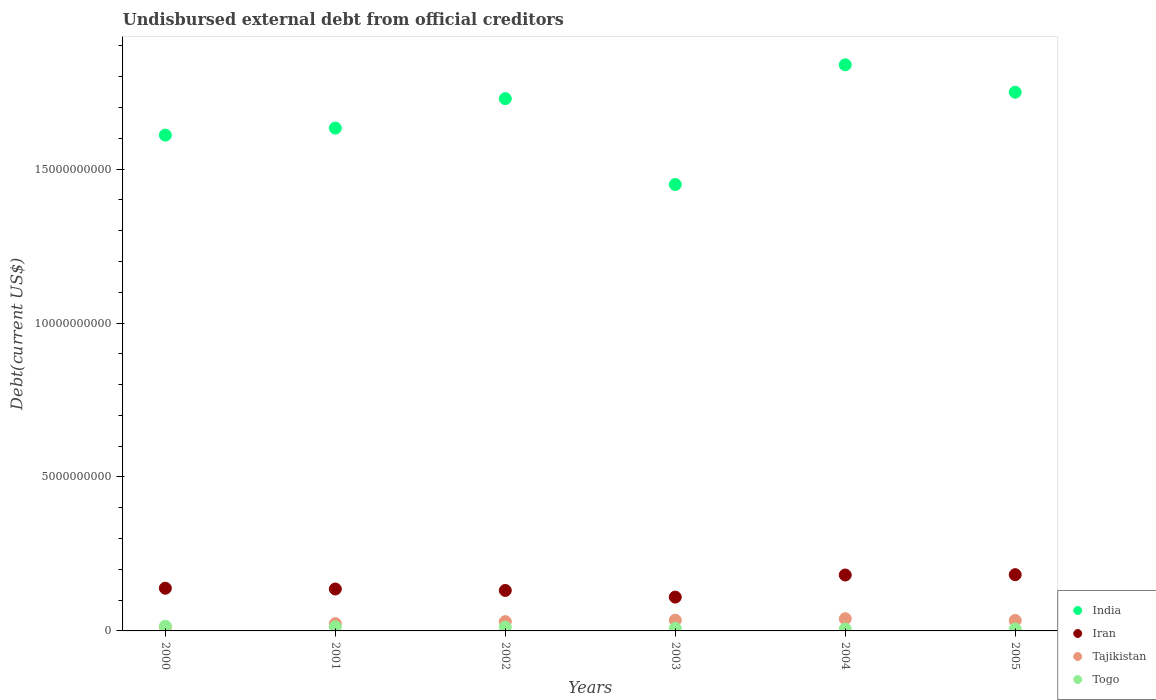Is the number of dotlines equal to the number of legend labels?
Make the answer very short. Yes. What is the total debt in Iran in 2004?
Keep it short and to the point. 1.82e+09. Across all years, what is the maximum total debt in Togo?
Provide a succinct answer. 1.53e+08. Across all years, what is the minimum total debt in Togo?
Offer a very short reply. 6.17e+07. What is the total total debt in Iran in the graph?
Offer a terse response. 8.80e+09. What is the difference between the total debt in Iran in 2000 and that in 2001?
Your answer should be very brief. 2.49e+07. What is the difference between the total debt in Iran in 2001 and the total debt in India in 2005?
Provide a succinct answer. -1.61e+1. What is the average total debt in India per year?
Offer a terse response. 1.67e+1. In the year 2002, what is the difference between the total debt in Tajikistan and total debt in Togo?
Your answer should be very brief. 1.81e+08. What is the ratio of the total debt in India in 2002 to that in 2003?
Provide a short and direct response. 1.19. Is the total debt in Togo in 2001 less than that in 2005?
Ensure brevity in your answer.  No. What is the difference between the highest and the second highest total debt in India?
Provide a short and direct response. 8.91e+08. What is the difference between the highest and the lowest total debt in Togo?
Keep it short and to the point. 9.15e+07. Is it the case that in every year, the sum of the total debt in Iran and total debt in Tajikistan  is greater than the total debt in Togo?
Your answer should be compact. Yes. Does the total debt in Tajikistan monotonically increase over the years?
Your response must be concise. No. Is the total debt in Iran strictly greater than the total debt in India over the years?
Provide a succinct answer. No. How many dotlines are there?
Offer a terse response. 4. How many years are there in the graph?
Provide a short and direct response. 6. Where does the legend appear in the graph?
Your answer should be very brief. Bottom right. How many legend labels are there?
Your response must be concise. 4. What is the title of the graph?
Provide a succinct answer. Undisbursed external debt from official creditors. Does "Samoa" appear as one of the legend labels in the graph?
Offer a very short reply. No. What is the label or title of the X-axis?
Keep it short and to the point. Years. What is the label or title of the Y-axis?
Your answer should be very brief. Debt(current US$). What is the Debt(current US$) of India in 2000?
Ensure brevity in your answer.  1.61e+1. What is the Debt(current US$) in Iran in 2000?
Provide a short and direct response. 1.39e+09. What is the Debt(current US$) of Tajikistan in 2000?
Your response must be concise. 1.18e+08. What is the Debt(current US$) of Togo in 2000?
Your answer should be very brief. 1.53e+08. What is the Debt(current US$) of India in 2001?
Offer a very short reply. 1.63e+1. What is the Debt(current US$) in Iran in 2001?
Make the answer very short. 1.36e+09. What is the Debt(current US$) in Tajikistan in 2001?
Your answer should be very brief. 2.36e+08. What is the Debt(current US$) in Togo in 2001?
Your response must be concise. 1.32e+08. What is the Debt(current US$) of India in 2002?
Your answer should be compact. 1.73e+1. What is the Debt(current US$) in Iran in 2002?
Ensure brevity in your answer.  1.31e+09. What is the Debt(current US$) in Tajikistan in 2002?
Your response must be concise. 3.02e+08. What is the Debt(current US$) of Togo in 2002?
Make the answer very short. 1.21e+08. What is the Debt(current US$) of India in 2003?
Your answer should be compact. 1.45e+1. What is the Debt(current US$) in Iran in 2003?
Your response must be concise. 1.10e+09. What is the Debt(current US$) of Tajikistan in 2003?
Offer a terse response. 3.47e+08. What is the Debt(current US$) in Togo in 2003?
Your answer should be compact. 8.25e+07. What is the Debt(current US$) of India in 2004?
Offer a terse response. 1.84e+1. What is the Debt(current US$) in Iran in 2004?
Provide a succinct answer. 1.82e+09. What is the Debt(current US$) of Tajikistan in 2004?
Keep it short and to the point. 3.96e+08. What is the Debt(current US$) in Togo in 2004?
Keep it short and to the point. 6.29e+07. What is the Debt(current US$) in India in 2005?
Make the answer very short. 1.75e+1. What is the Debt(current US$) of Iran in 2005?
Give a very brief answer. 1.83e+09. What is the Debt(current US$) of Tajikistan in 2005?
Your answer should be very brief. 3.39e+08. What is the Debt(current US$) in Togo in 2005?
Your response must be concise. 6.17e+07. Across all years, what is the maximum Debt(current US$) of India?
Offer a very short reply. 1.84e+1. Across all years, what is the maximum Debt(current US$) of Iran?
Provide a succinct answer. 1.83e+09. Across all years, what is the maximum Debt(current US$) of Tajikistan?
Provide a short and direct response. 3.96e+08. Across all years, what is the maximum Debt(current US$) of Togo?
Your answer should be very brief. 1.53e+08. Across all years, what is the minimum Debt(current US$) of India?
Offer a very short reply. 1.45e+1. Across all years, what is the minimum Debt(current US$) in Iran?
Your response must be concise. 1.10e+09. Across all years, what is the minimum Debt(current US$) in Tajikistan?
Give a very brief answer. 1.18e+08. Across all years, what is the minimum Debt(current US$) in Togo?
Provide a succinct answer. 6.17e+07. What is the total Debt(current US$) in India in the graph?
Give a very brief answer. 1.00e+11. What is the total Debt(current US$) in Iran in the graph?
Offer a very short reply. 8.80e+09. What is the total Debt(current US$) of Tajikistan in the graph?
Offer a terse response. 1.74e+09. What is the total Debt(current US$) of Togo in the graph?
Your answer should be compact. 6.13e+08. What is the difference between the Debt(current US$) of India in 2000 and that in 2001?
Keep it short and to the point. -2.29e+08. What is the difference between the Debt(current US$) of Iran in 2000 and that in 2001?
Provide a succinct answer. 2.49e+07. What is the difference between the Debt(current US$) in Tajikistan in 2000 and that in 2001?
Offer a very short reply. -1.18e+08. What is the difference between the Debt(current US$) in Togo in 2000 and that in 2001?
Keep it short and to the point. 2.13e+07. What is the difference between the Debt(current US$) of India in 2000 and that in 2002?
Offer a very short reply. -1.18e+09. What is the difference between the Debt(current US$) of Iran in 2000 and that in 2002?
Make the answer very short. 7.25e+07. What is the difference between the Debt(current US$) of Tajikistan in 2000 and that in 2002?
Ensure brevity in your answer.  -1.84e+08. What is the difference between the Debt(current US$) in Togo in 2000 and that in 2002?
Your answer should be compact. 3.19e+07. What is the difference between the Debt(current US$) of India in 2000 and that in 2003?
Your response must be concise. 1.60e+09. What is the difference between the Debt(current US$) of Iran in 2000 and that in 2003?
Your answer should be very brief. 2.88e+08. What is the difference between the Debt(current US$) of Tajikistan in 2000 and that in 2003?
Ensure brevity in your answer.  -2.30e+08. What is the difference between the Debt(current US$) in Togo in 2000 and that in 2003?
Your answer should be very brief. 7.07e+07. What is the difference between the Debt(current US$) of India in 2000 and that in 2004?
Ensure brevity in your answer.  -2.28e+09. What is the difference between the Debt(current US$) in Iran in 2000 and that in 2004?
Provide a succinct answer. -4.29e+08. What is the difference between the Debt(current US$) in Tajikistan in 2000 and that in 2004?
Ensure brevity in your answer.  -2.78e+08. What is the difference between the Debt(current US$) in Togo in 2000 and that in 2004?
Keep it short and to the point. 9.02e+07. What is the difference between the Debt(current US$) in India in 2000 and that in 2005?
Your response must be concise. -1.39e+09. What is the difference between the Debt(current US$) in Iran in 2000 and that in 2005?
Provide a succinct answer. -4.40e+08. What is the difference between the Debt(current US$) in Tajikistan in 2000 and that in 2005?
Provide a succinct answer. -2.22e+08. What is the difference between the Debt(current US$) of Togo in 2000 and that in 2005?
Keep it short and to the point. 9.15e+07. What is the difference between the Debt(current US$) in India in 2001 and that in 2002?
Offer a terse response. -9.56e+08. What is the difference between the Debt(current US$) in Iran in 2001 and that in 2002?
Your answer should be compact. 4.77e+07. What is the difference between the Debt(current US$) in Tajikistan in 2001 and that in 2002?
Keep it short and to the point. -6.63e+07. What is the difference between the Debt(current US$) of Togo in 2001 and that in 2002?
Ensure brevity in your answer.  1.05e+07. What is the difference between the Debt(current US$) in India in 2001 and that in 2003?
Make the answer very short. 1.83e+09. What is the difference between the Debt(current US$) in Iran in 2001 and that in 2003?
Your answer should be compact. 2.64e+08. What is the difference between the Debt(current US$) in Tajikistan in 2001 and that in 2003?
Make the answer very short. -1.12e+08. What is the difference between the Debt(current US$) of Togo in 2001 and that in 2003?
Your answer should be compact. 4.94e+07. What is the difference between the Debt(current US$) in India in 2001 and that in 2004?
Ensure brevity in your answer.  -2.06e+09. What is the difference between the Debt(current US$) of Iran in 2001 and that in 2004?
Keep it short and to the point. -4.54e+08. What is the difference between the Debt(current US$) of Tajikistan in 2001 and that in 2004?
Offer a terse response. -1.60e+08. What is the difference between the Debt(current US$) in Togo in 2001 and that in 2004?
Give a very brief answer. 6.89e+07. What is the difference between the Debt(current US$) of India in 2001 and that in 2005?
Provide a short and direct response. -1.16e+09. What is the difference between the Debt(current US$) of Iran in 2001 and that in 2005?
Provide a succinct answer. -4.65e+08. What is the difference between the Debt(current US$) in Tajikistan in 2001 and that in 2005?
Provide a short and direct response. -1.04e+08. What is the difference between the Debt(current US$) of Togo in 2001 and that in 2005?
Give a very brief answer. 7.02e+07. What is the difference between the Debt(current US$) of India in 2002 and that in 2003?
Your answer should be compact. 2.79e+09. What is the difference between the Debt(current US$) of Iran in 2002 and that in 2003?
Your answer should be very brief. 2.16e+08. What is the difference between the Debt(current US$) of Tajikistan in 2002 and that in 2003?
Provide a short and direct response. -4.55e+07. What is the difference between the Debt(current US$) in Togo in 2002 and that in 2003?
Offer a terse response. 3.88e+07. What is the difference between the Debt(current US$) in India in 2002 and that in 2004?
Ensure brevity in your answer.  -1.10e+09. What is the difference between the Debt(current US$) of Iran in 2002 and that in 2004?
Provide a short and direct response. -5.02e+08. What is the difference between the Debt(current US$) of Tajikistan in 2002 and that in 2004?
Your response must be concise. -9.41e+07. What is the difference between the Debt(current US$) in Togo in 2002 and that in 2004?
Offer a very short reply. 5.84e+07. What is the difference between the Debt(current US$) in India in 2002 and that in 2005?
Make the answer very short. -2.09e+08. What is the difference between the Debt(current US$) of Iran in 2002 and that in 2005?
Give a very brief answer. -5.12e+08. What is the difference between the Debt(current US$) in Tajikistan in 2002 and that in 2005?
Your answer should be compact. -3.75e+07. What is the difference between the Debt(current US$) of Togo in 2002 and that in 2005?
Provide a succinct answer. 5.96e+07. What is the difference between the Debt(current US$) of India in 2003 and that in 2004?
Keep it short and to the point. -3.89e+09. What is the difference between the Debt(current US$) of Iran in 2003 and that in 2004?
Offer a very short reply. -7.18e+08. What is the difference between the Debt(current US$) in Tajikistan in 2003 and that in 2004?
Offer a very short reply. -4.86e+07. What is the difference between the Debt(current US$) in Togo in 2003 and that in 2004?
Offer a very short reply. 1.96e+07. What is the difference between the Debt(current US$) of India in 2003 and that in 2005?
Give a very brief answer. -3.00e+09. What is the difference between the Debt(current US$) of Iran in 2003 and that in 2005?
Provide a short and direct response. -7.28e+08. What is the difference between the Debt(current US$) of Tajikistan in 2003 and that in 2005?
Keep it short and to the point. 8.02e+06. What is the difference between the Debt(current US$) in Togo in 2003 and that in 2005?
Ensure brevity in your answer.  2.08e+07. What is the difference between the Debt(current US$) of India in 2004 and that in 2005?
Offer a terse response. 8.91e+08. What is the difference between the Debt(current US$) in Iran in 2004 and that in 2005?
Give a very brief answer. -1.07e+07. What is the difference between the Debt(current US$) of Tajikistan in 2004 and that in 2005?
Your answer should be compact. 5.66e+07. What is the difference between the Debt(current US$) in Togo in 2004 and that in 2005?
Make the answer very short. 1.24e+06. What is the difference between the Debt(current US$) in India in 2000 and the Debt(current US$) in Iran in 2001?
Your answer should be very brief. 1.47e+1. What is the difference between the Debt(current US$) in India in 2000 and the Debt(current US$) in Tajikistan in 2001?
Make the answer very short. 1.59e+1. What is the difference between the Debt(current US$) of India in 2000 and the Debt(current US$) of Togo in 2001?
Make the answer very short. 1.60e+1. What is the difference between the Debt(current US$) in Iran in 2000 and the Debt(current US$) in Tajikistan in 2001?
Offer a very short reply. 1.15e+09. What is the difference between the Debt(current US$) in Iran in 2000 and the Debt(current US$) in Togo in 2001?
Make the answer very short. 1.25e+09. What is the difference between the Debt(current US$) in Tajikistan in 2000 and the Debt(current US$) in Togo in 2001?
Make the answer very short. -1.42e+07. What is the difference between the Debt(current US$) in India in 2000 and the Debt(current US$) in Iran in 2002?
Provide a succinct answer. 1.48e+1. What is the difference between the Debt(current US$) in India in 2000 and the Debt(current US$) in Tajikistan in 2002?
Make the answer very short. 1.58e+1. What is the difference between the Debt(current US$) of India in 2000 and the Debt(current US$) of Togo in 2002?
Make the answer very short. 1.60e+1. What is the difference between the Debt(current US$) in Iran in 2000 and the Debt(current US$) in Tajikistan in 2002?
Ensure brevity in your answer.  1.08e+09. What is the difference between the Debt(current US$) in Iran in 2000 and the Debt(current US$) in Togo in 2002?
Your response must be concise. 1.27e+09. What is the difference between the Debt(current US$) of Tajikistan in 2000 and the Debt(current US$) of Togo in 2002?
Give a very brief answer. -3.70e+06. What is the difference between the Debt(current US$) of India in 2000 and the Debt(current US$) of Iran in 2003?
Your answer should be compact. 1.50e+1. What is the difference between the Debt(current US$) in India in 2000 and the Debt(current US$) in Tajikistan in 2003?
Offer a very short reply. 1.58e+1. What is the difference between the Debt(current US$) of India in 2000 and the Debt(current US$) of Togo in 2003?
Your response must be concise. 1.60e+1. What is the difference between the Debt(current US$) in Iran in 2000 and the Debt(current US$) in Tajikistan in 2003?
Your answer should be very brief. 1.04e+09. What is the difference between the Debt(current US$) of Iran in 2000 and the Debt(current US$) of Togo in 2003?
Provide a short and direct response. 1.30e+09. What is the difference between the Debt(current US$) in Tajikistan in 2000 and the Debt(current US$) in Togo in 2003?
Ensure brevity in your answer.  3.51e+07. What is the difference between the Debt(current US$) in India in 2000 and the Debt(current US$) in Iran in 2004?
Provide a short and direct response. 1.43e+1. What is the difference between the Debt(current US$) in India in 2000 and the Debt(current US$) in Tajikistan in 2004?
Keep it short and to the point. 1.57e+1. What is the difference between the Debt(current US$) in India in 2000 and the Debt(current US$) in Togo in 2004?
Make the answer very short. 1.60e+1. What is the difference between the Debt(current US$) of Iran in 2000 and the Debt(current US$) of Tajikistan in 2004?
Make the answer very short. 9.91e+08. What is the difference between the Debt(current US$) in Iran in 2000 and the Debt(current US$) in Togo in 2004?
Your response must be concise. 1.32e+09. What is the difference between the Debt(current US$) in Tajikistan in 2000 and the Debt(current US$) in Togo in 2004?
Ensure brevity in your answer.  5.47e+07. What is the difference between the Debt(current US$) in India in 2000 and the Debt(current US$) in Iran in 2005?
Provide a succinct answer. 1.43e+1. What is the difference between the Debt(current US$) in India in 2000 and the Debt(current US$) in Tajikistan in 2005?
Offer a very short reply. 1.58e+1. What is the difference between the Debt(current US$) in India in 2000 and the Debt(current US$) in Togo in 2005?
Offer a very short reply. 1.60e+1. What is the difference between the Debt(current US$) in Iran in 2000 and the Debt(current US$) in Tajikistan in 2005?
Ensure brevity in your answer.  1.05e+09. What is the difference between the Debt(current US$) in Iran in 2000 and the Debt(current US$) in Togo in 2005?
Give a very brief answer. 1.33e+09. What is the difference between the Debt(current US$) in Tajikistan in 2000 and the Debt(current US$) in Togo in 2005?
Provide a succinct answer. 5.59e+07. What is the difference between the Debt(current US$) of India in 2001 and the Debt(current US$) of Iran in 2002?
Make the answer very short. 1.50e+1. What is the difference between the Debt(current US$) of India in 2001 and the Debt(current US$) of Tajikistan in 2002?
Your response must be concise. 1.60e+1. What is the difference between the Debt(current US$) in India in 2001 and the Debt(current US$) in Togo in 2002?
Make the answer very short. 1.62e+1. What is the difference between the Debt(current US$) in Iran in 2001 and the Debt(current US$) in Tajikistan in 2002?
Provide a succinct answer. 1.06e+09. What is the difference between the Debt(current US$) in Iran in 2001 and the Debt(current US$) in Togo in 2002?
Ensure brevity in your answer.  1.24e+09. What is the difference between the Debt(current US$) of Tajikistan in 2001 and the Debt(current US$) of Togo in 2002?
Keep it short and to the point. 1.14e+08. What is the difference between the Debt(current US$) of India in 2001 and the Debt(current US$) of Iran in 2003?
Provide a succinct answer. 1.52e+1. What is the difference between the Debt(current US$) of India in 2001 and the Debt(current US$) of Tajikistan in 2003?
Your answer should be compact. 1.60e+1. What is the difference between the Debt(current US$) of India in 2001 and the Debt(current US$) of Togo in 2003?
Give a very brief answer. 1.62e+1. What is the difference between the Debt(current US$) in Iran in 2001 and the Debt(current US$) in Tajikistan in 2003?
Offer a terse response. 1.01e+09. What is the difference between the Debt(current US$) in Iran in 2001 and the Debt(current US$) in Togo in 2003?
Provide a short and direct response. 1.28e+09. What is the difference between the Debt(current US$) in Tajikistan in 2001 and the Debt(current US$) in Togo in 2003?
Your answer should be compact. 1.53e+08. What is the difference between the Debt(current US$) in India in 2001 and the Debt(current US$) in Iran in 2004?
Make the answer very short. 1.45e+1. What is the difference between the Debt(current US$) of India in 2001 and the Debt(current US$) of Tajikistan in 2004?
Give a very brief answer. 1.59e+1. What is the difference between the Debt(current US$) in India in 2001 and the Debt(current US$) in Togo in 2004?
Ensure brevity in your answer.  1.63e+1. What is the difference between the Debt(current US$) of Iran in 2001 and the Debt(current US$) of Tajikistan in 2004?
Ensure brevity in your answer.  9.66e+08. What is the difference between the Debt(current US$) in Iran in 2001 and the Debt(current US$) in Togo in 2004?
Make the answer very short. 1.30e+09. What is the difference between the Debt(current US$) in Tajikistan in 2001 and the Debt(current US$) in Togo in 2004?
Your response must be concise. 1.73e+08. What is the difference between the Debt(current US$) in India in 2001 and the Debt(current US$) in Iran in 2005?
Give a very brief answer. 1.45e+1. What is the difference between the Debt(current US$) of India in 2001 and the Debt(current US$) of Tajikistan in 2005?
Provide a succinct answer. 1.60e+1. What is the difference between the Debt(current US$) of India in 2001 and the Debt(current US$) of Togo in 2005?
Ensure brevity in your answer.  1.63e+1. What is the difference between the Debt(current US$) of Iran in 2001 and the Debt(current US$) of Tajikistan in 2005?
Keep it short and to the point. 1.02e+09. What is the difference between the Debt(current US$) of Iran in 2001 and the Debt(current US$) of Togo in 2005?
Your answer should be compact. 1.30e+09. What is the difference between the Debt(current US$) of Tajikistan in 2001 and the Debt(current US$) of Togo in 2005?
Offer a terse response. 1.74e+08. What is the difference between the Debt(current US$) in India in 2002 and the Debt(current US$) in Iran in 2003?
Provide a short and direct response. 1.62e+1. What is the difference between the Debt(current US$) in India in 2002 and the Debt(current US$) in Tajikistan in 2003?
Your answer should be compact. 1.69e+1. What is the difference between the Debt(current US$) of India in 2002 and the Debt(current US$) of Togo in 2003?
Give a very brief answer. 1.72e+1. What is the difference between the Debt(current US$) of Iran in 2002 and the Debt(current US$) of Tajikistan in 2003?
Your response must be concise. 9.67e+08. What is the difference between the Debt(current US$) in Iran in 2002 and the Debt(current US$) in Togo in 2003?
Offer a very short reply. 1.23e+09. What is the difference between the Debt(current US$) of Tajikistan in 2002 and the Debt(current US$) of Togo in 2003?
Make the answer very short. 2.19e+08. What is the difference between the Debt(current US$) of India in 2002 and the Debt(current US$) of Iran in 2004?
Provide a succinct answer. 1.55e+1. What is the difference between the Debt(current US$) of India in 2002 and the Debt(current US$) of Tajikistan in 2004?
Offer a very short reply. 1.69e+1. What is the difference between the Debt(current US$) of India in 2002 and the Debt(current US$) of Togo in 2004?
Your answer should be compact. 1.72e+1. What is the difference between the Debt(current US$) in Iran in 2002 and the Debt(current US$) in Tajikistan in 2004?
Provide a succinct answer. 9.18e+08. What is the difference between the Debt(current US$) of Iran in 2002 and the Debt(current US$) of Togo in 2004?
Give a very brief answer. 1.25e+09. What is the difference between the Debt(current US$) of Tajikistan in 2002 and the Debt(current US$) of Togo in 2004?
Offer a very short reply. 2.39e+08. What is the difference between the Debt(current US$) in India in 2002 and the Debt(current US$) in Iran in 2005?
Make the answer very short. 1.55e+1. What is the difference between the Debt(current US$) in India in 2002 and the Debt(current US$) in Tajikistan in 2005?
Keep it short and to the point. 1.69e+1. What is the difference between the Debt(current US$) in India in 2002 and the Debt(current US$) in Togo in 2005?
Your answer should be compact. 1.72e+1. What is the difference between the Debt(current US$) of Iran in 2002 and the Debt(current US$) of Tajikistan in 2005?
Give a very brief answer. 9.75e+08. What is the difference between the Debt(current US$) in Iran in 2002 and the Debt(current US$) in Togo in 2005?
Make the answer very short. 1.25e+09. What is the difference between the Debt(current US$) of Tajikistan in 2002 and the Debt(current US$) of Togo in 2005?
Your answer should be very brief. 2.40e+08. What is the difference between the Debt(current US$) in India in 2003 and the Debt(current US$) in Iran in 2004?
Offer a terse response. 1.27e+1. What is the difference between the Debt(current US$) in India in 2003 and the Debt(current US$) in Tajikistan in 2004?
Your answer should be compact. 1.41e+1. What is the difference between the Debt(current US$) of India in 2003 and the Debt(current US$) of Togo in 2004?
Offer a terse response. 1.44e+1. What is the difference between the Debt(current US$) in Iran in 2003 and the Debt(current US$) in Tajikistan in 2004?
Give a very brief answer. 7.02e+08. What is the difference between the Debt(current US$) of Iran in 2003 and the Debt(current US$) of Togo in 2004?
Your answer should be very brief. 1.04e+09. What is the difference between the Debt(current US$) in Tajikistan in 2003 and the Debt(current US$) in Togo in 2004?
Your answer should be very brief. 2.84e+08. What is the difference between the Debt(current US$) of India in 2003 and the Debt(current US$) of Iran in 2005?
Keep it short and to the point. 1.27e+1. What is the difference between the Debt(current US$) of India in 2003 and the Debt(current US$) of Tajikistan in 2005?
Provide a short and direct response. 1.42e+1. What is the difference between the Debt(current US$) in India in 2003 and the Debt(current US$) in Togo in 2005?
Provide a short and direct response. 1.44e+1. What is the difference between the Debt(current US$) in Iran in 2003 and the Debt(current US$) in Tajikistan in 2005?
Offer a terse response. 7.59e+08. What is the difference between the Debt(current US$) in Iran in 2003 and the Debt(current US$) in Togo in 2005?
Give a very brief answer. 1.04e+09. What is the difference between the Debt(current US$) of Tajikistan in 2003 and the Debt(current US$) of Togo in 2005?
Offer a terse response. 2.86e+08. What is the difference between the Debt(current US$) in India in 2004 and the Debt(current US$) in Iran in 2005?
Keep it short and to the point. 1.66e+1. What is the difference between the Debt(current US$) in India in 2004 and the Debt(current US$) in Tajikistan in 2005?
Offer a terse response. 1.80e+1. What is the difference between the Debt(current US$) of India in 2004 and the Debt(current US$) of Togo in 2005?
Provide a succinct answer. 1.83e+1. What is the difference between the Debt(current US$) in Iran in 2004 and the Debt(current US$) in Tajikistan in 2005?
Make the answer very short. 1.48e+09. What is the difference between the Debt(current US$) in Iran in 2004 and the Debt(current US$) in Togo in 2005?
Your answer should be compact. 1.75e+09. What is the difference between the Debt(current US$) of Tajikistan in 2004 and the Debt(current US$) of Togo in 2005?
Your answer should be compact. 3.34e+08. What is the average Debt(current US$) of India per year?
Ensure brevity in your answer.  1.67e+1. What is the average Debt(current US$) of Iran per year?
Ensure brevity in your answer.  1.47e+09. What is the average Debt(current US$) in Tajikistan per year?
Make the answer very short. 2.90e+08. What is the average Debt(current US$) of Togo per year?
Provide a succinct answer. 1.02e+08. In the year 2000, what is the difference between the Debt(current US$) of India and Debt(current US$) of Iran?
Your answer should be very brief. 1.47e+1. In the year 2000, what is the difference between the Debt(current US$) in India and Debt(current US$) in Tajikistan?
Ensure brevity in your answer.  1.60e+1. In the year 2000, what is the difference between the Debt(current US$) of India and Debt(current US$) of Togo?
Provide a succinct answer. 1.59e+1. In the year 2000, what is the difference between the Debt(current US$) of Iran and Debt(current US$) of Tajikistan?
Give a very brief answer. 1.27e+09. In the year 2000, what is the difference between the Debt(current US$) in Iran and Debt(current US$) in Togo?
Offer a very short reply. 1.23e+09. In the year 2000, what is the difference between the Debt(current US$) in Tajikistan and Debt(current US$) in Togo?
Give a very brief answer. -3.56e+07. In the year 2001, what is the difference between the Debt(current US$) of India and Debt(current US$) of Iran?
Offer a very short reply. 1.50e+1. In the year 2001, what is the difference between the Debt(current US$) in India and Debt(current US$) in Tajikistan?
Ensure brevity in your answer.  1.61e+1. In the year 2001, what is the difference between the Debt(current US$) of India and Debt(current US$) of Togo?
Make the answer very short. 1.62e+1. In the year 2001, what is the difference between the Debt(current US$) of Iran and Debt(current US$) of Tajikistan?
Give a very brief answer. 1.13e+09. In the year 2001, what is the difference between the Debt(current US$) in Iran and Debt(current US$) in Togo?
Give a very brief answer. 1.23e+09. In the year 2001, what is the difference between the Debt(current US$) in Tajikistan and Debt(current US$) in Togo?
Ensure brevity in your answer.  1.04e+08. In the year 2002, what is the difference between the Debt(current US$) in India and Debt(current US$) in Iran?
Provide a succinct answer. 1.60e+1. In the year 2002, what is the difference between the Debt(current US$) in India and Debt(current US$) in Tajikistan?
Provide a succinct answer. 1.70e+1. In the year 2002, what is the difference between the Debt(current US$) in India and Debt(current US$) in Togo?
Your answer should be very brief. 1.72e+1. In the year 2002, what is the difference between the Debt(current US$) of Iran and Debt(current US$) of Tajikistan?
Provide a short and direct response. 1.01e+09. In the year 2002, what is the difference between the Debt(current US$) of Iran and Debt(current US$) of Togo?
Offer a very short reply. 1.19e+09. In the year 2002, what is the difference between the Debt(current US$) of Tajikistan and Debt(current US$) of Togo?
Provide a succinct answer. 1.81e+08. In the year 2003, what is the difference between the Debt(current US$) of India and Debt(current US$) of Iran?
Your response must be concise. 1.34e+1. In the year 2003, what is the difference between the Debt(current US$) of India and Debt(current US$) of Tajikistan?
Keep it short and to the point. 1.42e+1. In the year 2003, what is the difference between the Debt(current US$) of India and Debt(current US$) of Togo?
Offer a terse response. 1.44e+1. In the year 2003, what is the difference between the Debt(current US$) of Iran and Debt(current US$) of Tajikistan?
Offer a very short reply. 7.51e+08. In the year 2003, what is the difference between the Debt(current US$) in Iran and Debt(current US$) in Togo?
Ensure brevity in your answer.  1.02e+09. In the year 2003, what is the difference between the Debt(current US$) in Tajikistan and Debt(current US$) in Togo?
Make the answer very short. 2.65e+08. In the year 2004, what is the difference between the Debt(current US$) of India and Debt(current US$) of Iran?
Your answer should be compact. 1.66e+1. In the year 2004, what is the difference between the Debt(current US$) of India and Debt(current US$) of Tajikistan?
Make the answer very short. 1.80e+1. In the year 2004, what is the difference between the Debt(current US$) in India and Debt(current US$) in Togo?
Your response must be concise. 1.83e+1. In the year 2004, what is the difference between the Debt(current US$) of Iran and Debt(current US$) of Tajikistan?
Offer a terse response. 1.42e+09. In the year 2004, what is the difference between the Debt(current US$) of Iran and Debt(current US$) of Togo?
Keep it short and to the point. 1.75e+09. In the year 2004, what is the difference between the Debt(current US$) in Tajikistan and Debt(current US$) in Togo?
Give a very brief answer. 3.33e+08. In the year 2005, what is the difference between the Debt(current US$) of India and Debt(current US$) of Iran?
Your answer should be very brief. 1.57e+1. In the year 2005, what is the difference between the Debt(current US$) in India and Debt(current US$) in Tajikistan?
Offer a terse response. 1.72e+1. In the year 2005, what is the difference between the Debt(current US$) of India and Debt(current US$) of Togo?
Provide a succinct answer. 1.74e+1. In the year 2005, what is the difference between the Debt(current US$) of Iran and Debt(current US$) of Tajikistan?
Keep it short and to the point. 1.49e+09. In the year 2005, what is the difference between the Debt(current US$) of Iran and Debt(current US$) of Togo?
Your answer should be compact. 1.77e+09. In the year 2005, what is the difference between the Debt(current US$) in Tajikistan and Debt(current US$) in Togo?
Provide a succinct answer. 2.78e+08. What is the ratio of the Debt(current US$) in India in 2000 to that in 2001?
Keep it short and to the point. 0.99. What is the ratio of the Debt(current US$) in Iran in 2000 to that in 2001?
Provide a succinct answer. 1.02. What is the ratio of the Debt(current US$) of Tajikistan in 2000 to that in 2001?
Offer a terse response. 0.5. What is the ratio of the Debt(current US$) in Togo in 2000 to that in 2001?
Make the answer very short. 1.16. What is the ratio of the Debt(current US$) of India in 2000 to that in 2002?
Give a very brief answer. 0.93. What is the ratio of the Debt(current US$) in Iran in 2000 to that in 2002?
Ensure brevity in your answer.  1.06. What is the ratio of the Debt(current US$) in Tajikistan in 2000 to that in 2002?
Give a very brief answer. 0.39. What is the ratio of the Debt(current US$) in Togo in 2000 to that in 2002?
Provide a succinct answer. 1.26. What is the ratio of the Debt(current US$) of India in 2000 to that in 2003?
Offer a terse response. 1.11. What is the ratio of the Debt(current US$) of Iran in 2000 to that in 2003?
Your answer should be very brief. 1.26. What is the ratio of the Debt(current US$) in Tajikistan in 2000 to that in 2003?
Provide a succinct answer. 0.34. What is the ratio of the Debt(current US$) in Togo in 2000 to that in 2003?
Provide a short and direct response. 1.86. What is the ratio of the Debt(current US$) in India in 2000 to that in 2004?
Give a very brief answer. 0.88. What is the ratio of the Debt(current US$) in Iran in 2000 to that in 2004?
Your answer should be very brief. 0.76. What is the ratio of the Debt(current US$) of Tajikistan in 2000 to that in 2004?
Offer a terse response. 0.3. What is the ratio of the Debt(current US$) in Togo in 2000 to that in 2004?
Your answer should be very brief. 2.43. What is the ratio of the Debt(current US$) in India in 2000 to that in 2005?
Your answer should be very brief. 0.92. What is the ratio of the Debt(current US$) in Iran in 2000 to that in 2005?
Offer a terse response. 0.76. What is the ratio of the Debt(current US$) of Tajikistan in 2000 to that in 2005?
Ensure brevity in your answer.  0.35. What is the ratio of the Debt(current US$) of Togo in 2000 to that in 2005?
Ensure brevity in your answer.  2.48. What is the ratio of the Debt(current US$) in India in 2001 to that in 2002?
Your response must be concise. 0.94. What is the ratio of the Debt(current US$) in Iran in 2001 to that in 2002?
Offer a terse response. 1.04. What is the ratio of the Debt(current US$) in Tajikistan in 2001 to that in 2002?
Give a very brief answer. 0.78. What is the ratio of the Debt(current US$) in Togo in 2001 to that in 2002?
Keep it short and to the point. 1.09. What is the ratio of the Debt(current US$) of India in 2001 to that in 2003?
Make the answer very short. 1.13. What is the ratio of the Debt(current US$) in Iran in 2001 to that in 2003?
Provide a short and direct response. 1.24. What is the ratio of the Debt(current US$) in Tajikistan in 2001 to that in 2003?
Your response must be concise. 0.68. What is the ratio of the Debt(current US$) in Togo in 2001 to that in 2003?
Your answer should be very brief. 1.6. What is the ratio of the Debt(current US$) in India in 2001 to that in 2004?
Offer a very short reply. 0.89. What is the ratio of the Debt(current US$) of Iran in 2001 to that in 2004?
Keep it short and to the point. 0.75. What is the ratio of the Debt(current US$) in Tajikistan in 2001 to that in 2004?
Make the answer very short. 0.59. What is the ratio of the Debt(current US$) of Togo in 2001 to that in 2004?
Your response must be concise. 2.1. What is the ratio of the Debt(current US$) of India in 2001 to that in 2005?
Keep it short and to the point. 0.93. What is the ratio of the Debt(current US$) of Iran in 2001 to that in 2005?
Provide a succinct answer. 0.75. What is the ratio of the Debt(current US$) of Tajikistan in 2001 to that in 2005?
Make the answer very short. 0.69. What is the ratio of the Debt(current US$) in Togo in 2001 to that in 2005?
Provide a short and direct response. 2.14. What is the ratio of the Debt(current US$) in India in 2002 to that in 2003?
Provide a succinct answer. 1.19. What is the ratio of the Debt(current US$) in Iran in 2002 to that in 2003?
Keep it short and to the point. 1.2. What is the ratio of the Debt(current US$) in Tajikistan in 2002 to that in 2003?
Ensure brevity in your answer.  0.87. What is the ratio of the Debt(current US$) in Togo in 2002 to that in 2003?
Make the answer very short. 1.47. What is the ratio of the Debt(current US$) in India in 2002 to that in 2004?
Your answer should be compact. 0.94. What is the ratio of the Debt(current US$) in Iran in 2002 to that in 2004?
Give a very brief answer. 0.72. What is the ratio of the Debt(current US$) of Tajikistan in 2002 to that in 2004?
Keep it short and to the point. 0.76. What is the ratio of the Debt(current US$) of Togo in 2002 to that in 2004?
Make the answer very short. 1.93. What is the ratio of the Debt(current US$) in India in 2002 to that in 2005?
Make the answer very short. 0.99. What is the ratio of the Debt(current US$) in Iran in 2002 to that in 2005?
Ensure brevity in your answer.  0.72. What is the ratio of the Debt(current US$) of Tajikistan in 2002 to that in 2005?
Your answer should be compact. 0.89. What is the ratio of the Debt(current US$) in Togo in 2002 to that in 2005?
Provide a succinct answer. 1.97. What is the ratio of the Debt(current US$) of India in 2003 to that in 2004?
Make the answer very short. 0.79. What is the ratio of the Debt(current US$) of Iran in 2003 to that in 2004?
Ensure brevity in your answer.  0.6. What is the ratio of the Debt(current US$) in Tajikistan in 2003 to that in 2004?
Offer a very short reply. 0.88. What is the ratio of the Debt(current US$) in Togo in 2003 to that in 2004?
Provide a short and direct response. 1.31. What is the ratio of the Debt(current US$) in India in 2003 to that in 2005?
Provide a succinct answer. 0.83. What is the ratio of the Debt(current US$) in Iran in 2003 to that in 2005?
Offer a terse response. 0.6. What is the ratio of the Debt(current US$) in Tajikistan in 2003 to that in 2005?
Provide a succinct answer. 1.02. What is the ratio of the Debt(current US$) in Togo in 2003 to that in 2005?
Provide a short and direct response. 1.34. What is the ratio of the Debt(current US$) in India in 2004 to that in 2005?
Your answer should be compact. 1.05. What is the ratio of the Debt(current US$) of Tajikistan in 2004 to that in 2005?
Ensure brevity in your answer.  1.17. What is the ratio of the Debt(current US$) of Togo in 2004 to that in 2005?
Offer a very short reply. 1.02. What is the difference between the highest and the second highest Debt(current US$) of India?
Provide a succinct answer. 8.91e+08. What is the difference between the highest and the second highest Debt(current US$) in Iran?
Make the answer very short. 1.07e+07. What is the difference between the highest and the second highest Debt(current US$) in Tajikistan?
Ensure brevity in your answer.  4.86e+07. What is the difference between the highest and the second highest Debt(current US$) in Togo?
Make the answer very short. 2.13e+07. What is the difference between the highest and the lowest Debt(current US$) of India?
Your answer should be very brief. 3.89e+09. What is the difference between the highest and the lowest Debt(current US$) in Iran?
Make the answer very short. 7.28e+08. What is the difference between the highest and the lowest Debt(current US$) of Tajikistan?
Provide a succinct answer. 2.78e+08. What is the difference between the highest and the lowest Debt(current US$) in Togo?
Provide a short and direct response. 9.15e+07. 